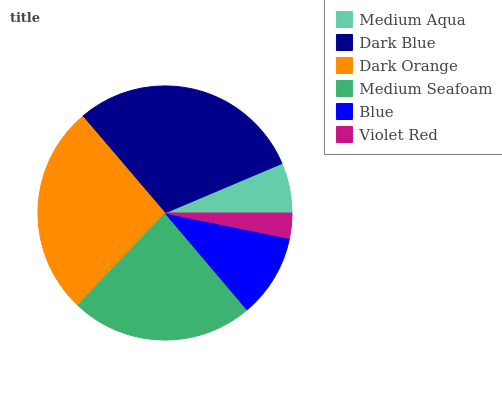Is Violet Red the minimum?
Answer yes or no. Yes. Is Dark Blue the maximum?
Answer yes or no. Yes. Is Dark Orange the minimum?
Answer yes or no. No. Is Dark Orange the maximum?
Answer yes or no. No. Is Dark Blue greater than Dark Orange?
Answer yes or no. Yes. Is Dark Orange less than Dark Blue?
Answer yes or no. Yes. Is Dark Orange greater than Dark Blue?
Answer yes or no. No. Is Dark Blue less than Dark Orange?
Answer yes or no. No. Is Medium Seafoam the high median?
Answer yes or no. Yes. Is Blue the low median?
Answer yes or no. Yes. Is Dark Orange the high median?
Answer yes or no. No. Is Dark Orange the low median?
Answer yes or no. No. 